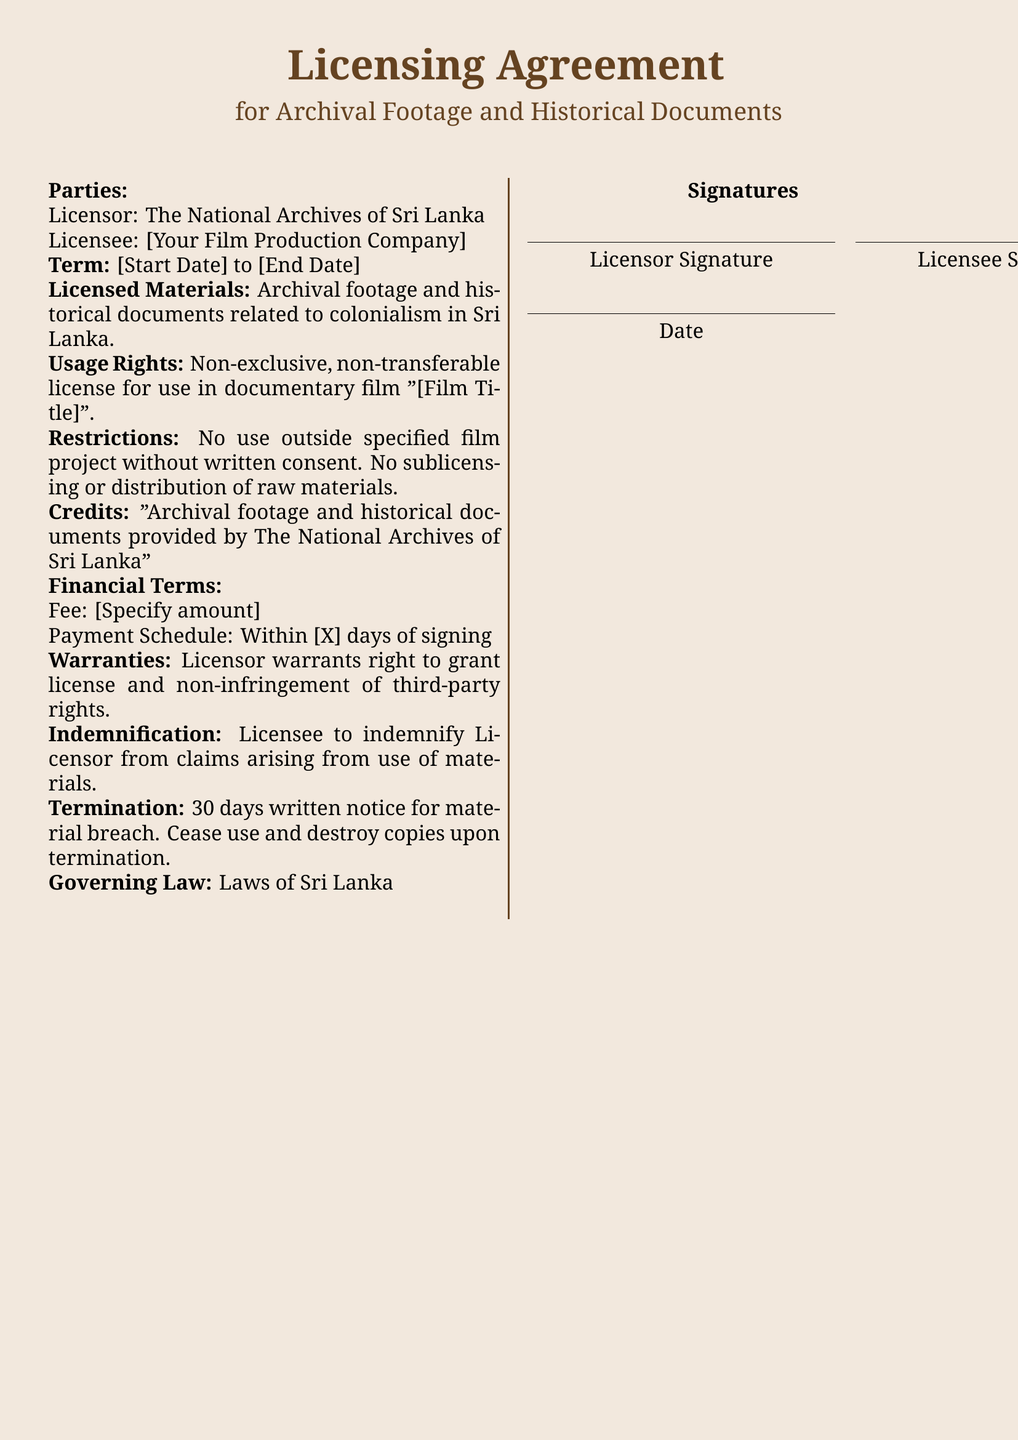What is the name of the Licensor? The Licensor is identified as The National Archives of Sri Lanka in the document.
Answer: The National Archives of Sri Lanka What is the term duration of the license? The document specifies a start date and an end date for the term, which are placeholders in the agreement.
Answer: [Start Date] to [End Date] What is the title of the documentary film? The document states that the licensed materials are for use in a documentary film titled "[Film Title]."
Answer: [Film Title] What type of license is granted? The document mentions that the license is non-exclusive and non-transferable.
Answer: Non-exclusive, non-transferable What must be included in the credits? The document specifies that credits must state "Archival footage and historical documents provided by The National Archives of Sri Lanka."
Answer: Archival footage and historical documents provided by The National Archives of Sri Lanka What is the payment schedule required? The document indicates that payment must be made within a specified number of days after signing.
Answer: Within [X] days of signing What is the governing law mentioned in the document? The document specifies that the governing law will be the laws of Sri Lanka.
Answer: Laws of Sri Lanka How many days notice is required for termination? The document states that 30 days written notice is required for termination due to material breach.
Answer: 30 days What is the financial term mentioned for the fee? The document includes a placeholder indicating that an amount must be specified for the fee.
Answer: [Specify amount] 